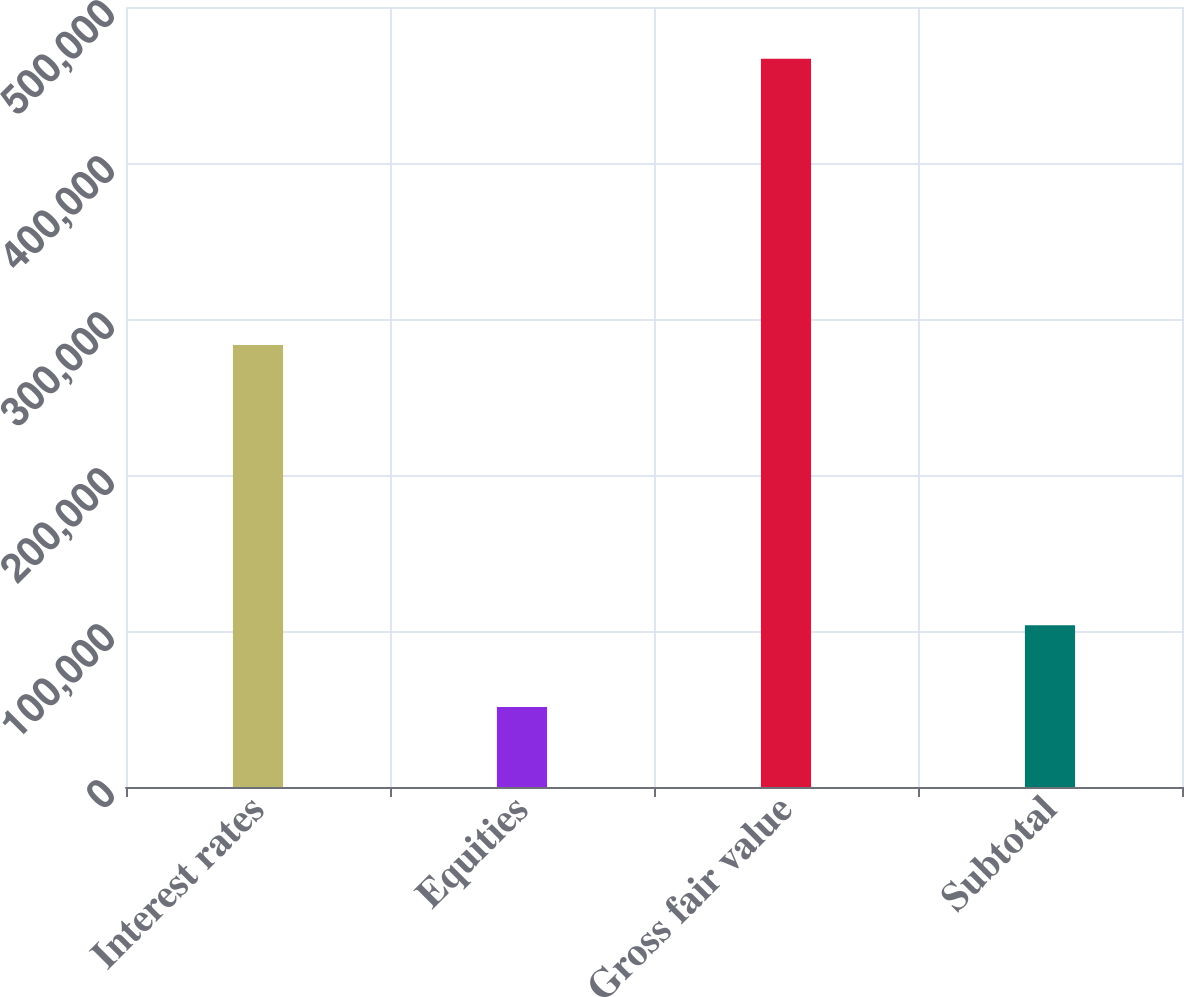Convert chart to OTSL. <chart><loc_0><loc_0><loc_500><loc_500><bar_chart><fcel>Interest rates<fcel>Equities<fcel>Gross fair value<fcel>Subtotal<nl><fcel>283262<fcel>51287<fcel>466863<fcel>103703<nl></chart> 